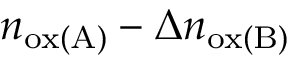<formula> <loc_0><loc_0><loc_500><loc_500>n _ { o x ( A ) } - \Delta n _ { o x ( B ) }</formula> 